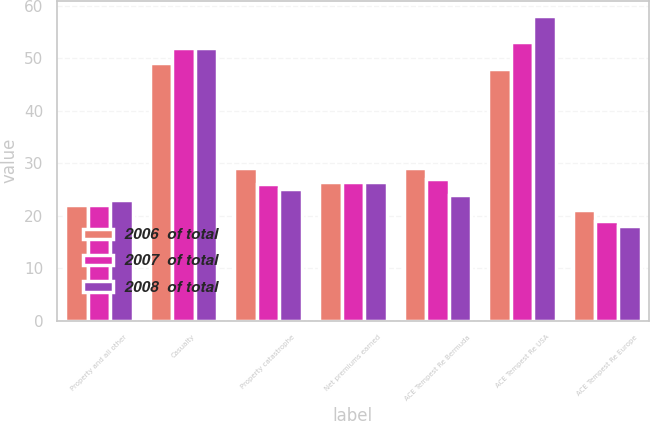Convert chart to OTSL. <chart><loc_0><loc_0><loc_500><loc_500><stacked_bar_chart><ecel><fcel>Property and all other<fcel>Casualty<fcel>Property catastrophe<fcel>Net premiums earned<fcel>ACE Tempest Re Bermuda<fcel>ACE Tempest Re USA<fcel>ACE Tempest Re Europe<nl><fcel>2006  of total<fcel>22<fcel>49<fcel>29<fcel>26.5<fcel>29<fcel>48<fcel>21<nl><fcel>2007  of total<fcel>22<fcel>52<fcel>26<fcel>26.5<fcel>27<fcel>53<fcel>19<nl><fcel>2008  of total<fcel>23<fcel>52<fcel>25<fcel>26.5<fcel>24<fcel>58<fcel>18<nl></chart> 